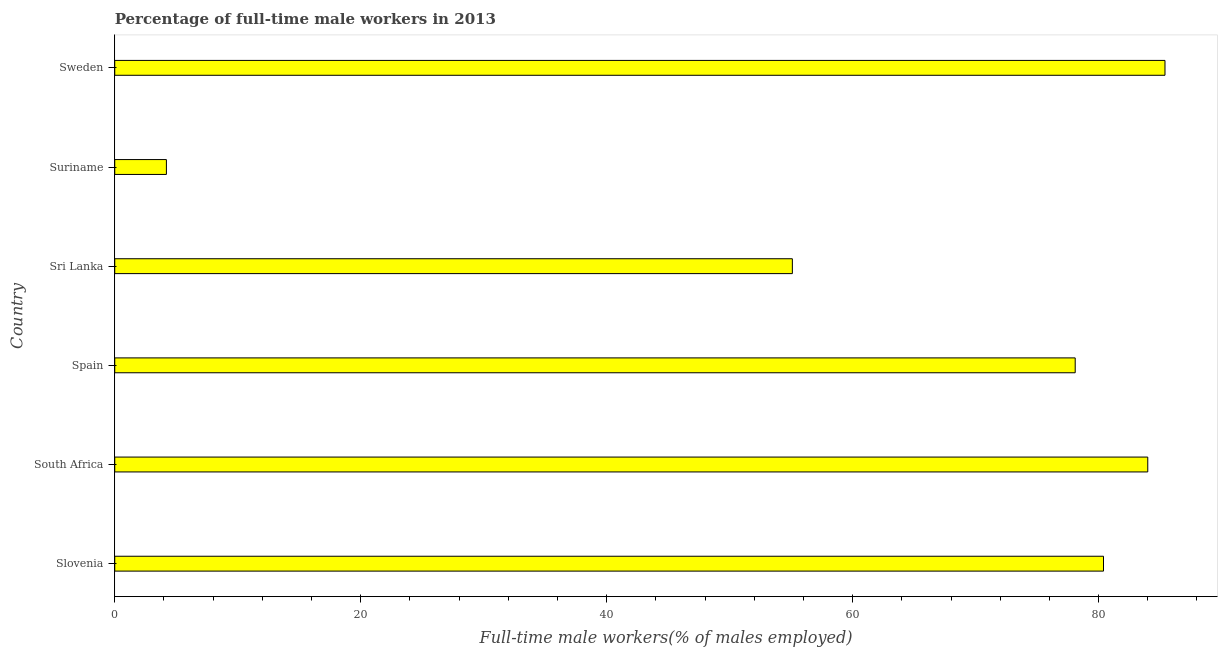What is the title of the graph?
Offer a terse response. Percentage of full-time male workers in 2013. What is the label or title of the X-axis?
Your answer should be compact. Full-time male workers(% of males employed). What is the percentage of full-time male workers in Spain?
Keep it short and to the point. 78.1. Across all countries, what is the maximum percentage of full-time male workers?
Offer a terse response. 85.4. Across all countries, what is the minimum percentage of full-time male workers?
Offer a terse response. 4.2. In which country was the percentage of full-time male workers maximum?
Make the answer very short. Sweden. In which country was the percentage of full-time male workers minimum?
Provide a short and direct response. Suriname. What is the sum of the percentage of full-time male workers?
Your response must be concise. 387.2. What is the difference between the percentage of full-time male workers in South Africa and Sweden?
Keep it short and to the point. -1.4. What is the average percentage of full-time male workers per country?
Make the answer very short. 64.53. What is the median percentage of full-time male workers?
Provide a succinct answer. 79.25. What is the ratio of the percentage of full-time male workers in Sri Lanka to that in Sweden?
Give a very brief answer. 0.65. Is the difference between the percentage of full-time male workers in Slovenia and Spain greater than the difference between any two countries?
Your response must be concise. No. What is the difference between the highest and the second highest percentage of full-time male workers?
Your response must be concise. 1.4. What is the difference between the highest and the lowest percentage of full-time male workers?
Your answer should be very brief. 81.2. How many bars are there?
Your answer should be very brief. 6. Are all the bars in the graph horizontal?
Provide a succinct answer. Yes. How many countries are there in the graph?
Keep it short and to the point. 6. What is the Full-time male workers(% of males employed) in Slovenia?
Your response must be concise. 80.4. What is the Full-time male workers(% of males employed) of Spain?
Provide a short and direct response. 78.1. What is the Full-time male workers(% of males employed) in Sri Lanka?
Ensure brevity in your answer.  55.1. What is the Full-time male workers(% of males employed) in Suriname?
Your response must be concise. 4.2. What is the Full-time male workers(% of males employed) in Sweden?
Keep it short and to the point. 85.4. What is the difference between the Full-time male workers(% of males employed) in Slovenia and South Africa?
Ensure brevity in your answer.  -3.6. What is the difference between the Full-time male workers(% of males employed) in Slovenia and Spain?
Your response must be concise. 2.3. What is the difference between the Full-time male workers(% of males employed) in Slovenia and Sri Lanka?
Your response must be concise. 25.3. What is the difference between the Full-time male workers(% of males employed) in Slovenia and Suriname?
Your answer should be compact. 76.2. What is the difference between the Full-time male workers(% of males employed) in Slovenia and Sweden?
Provide a succinct answer. -5. What is the difference between the Full-time male workers(% of males employed) in South Africa and Sri Lanka?
Offer a very short reply. 28.9. What is the difference between the Full-time male workers(% of males employed) in South Africa and Suriname?
Offer a very short reply. 79.8. What is the difference between the Full-time male workers(% of males employed) in South Africa and Sweden?
Your answer should be very brief. -1.4. What is the difference between the Full-time male workers(% of males employed) in Spain and Suriname?
Ensure brevity in your answer.  73.9. What is the difference between the Full-time male workers(% of males employed) in Sri Lanka and Suriname?
Offer a very short reply. 50.9. What is the difference between the Full-time male workers(% of males employed) in Sri Lanka and Sweden?
Make the answer very short. -30.3. What is the difference between the Full-time male workers(% of males employed) in Suriname and Sweden?
Provide a short and direct response. -81.2. What is the ratio of the Full-time male workers(% of males employed) in Slovenia to that in Sri Lanka?
Provide a succinct answer. 1.46. What is the ratio of the Full-time male workers(% of males employed) in Slovenia to that in Suriname?
Keep it short and to the point. 19.14. What is the ratio of the Full-time male workers(% of males employed) in Slovenia to that in Sweden?
Provide a succinct answer. 0.94. What is the ratio of the Full-time male workers(% of males employed) in South Africa to that in Spain?
Offer a very short reply. 1.08. What is the ratio of the Full-time male workers(% of males employed) in South Africa to that in Sri Lanka?
Provide a short and direct response. 1.52. What is the ratio of the Full-time male workers(% of males employed) in Spain to that in Sri Lanka?
Provide a succinct answer. 1.42. What is the ratio of the Full-time male workers(% of males employed) in Spain to that in Suriname?
Ensure brevity in your answer.  18.59. What is the ratio of the Full-time male workers(% of males employed) in Spain to that in Sweden?
Keep it short and to the point. 0.92. What is the ratio of the Full-time male workers(% of males employed) in Sri Lanka to that in Suriname?
Offer a very short reply. 13.12. What is the ratio of the Full-time male workers(% of males employed) in Sri Lanka to that in Sweden?
Your response must be concise. 0.65. What is the ratio of the Full-time male workers(% of males employed) in Suriname to that in Sweden?
Offer a very short reply. 0.05. 